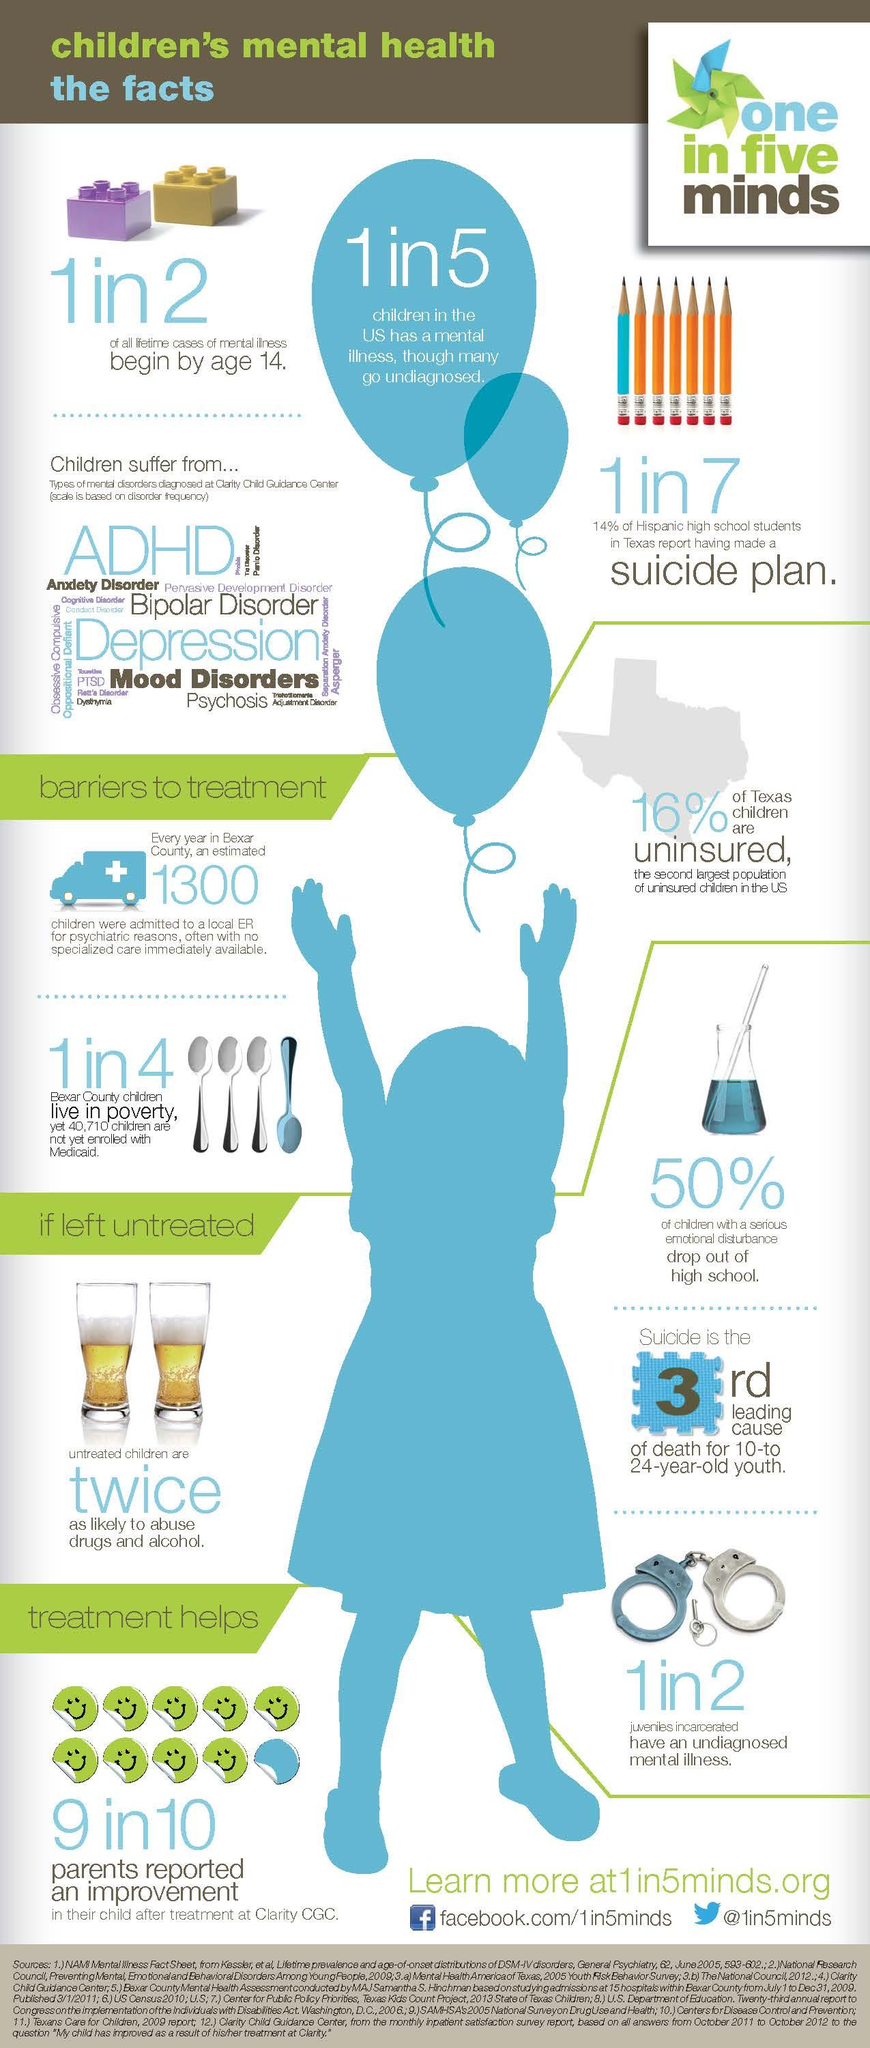Identify some key points in this picture. According to a recent estimate, approximately 20% of children in the United States are affected by mental illness, despite the fact that many go undiagnosed. According to recent data, approximately 25% of children in Bexar County are living in poverty. The second largest population of uninsured children in the United States is located in Texas. It is estimated that approximately 50% of all lifetime cases of mental illness begin by the age of 14. Attention Deficit Hyperactivity Disorder (ADHD) and Major Depressive Disorder (MDD) are two of the most common mental disorders that children suffer from. 